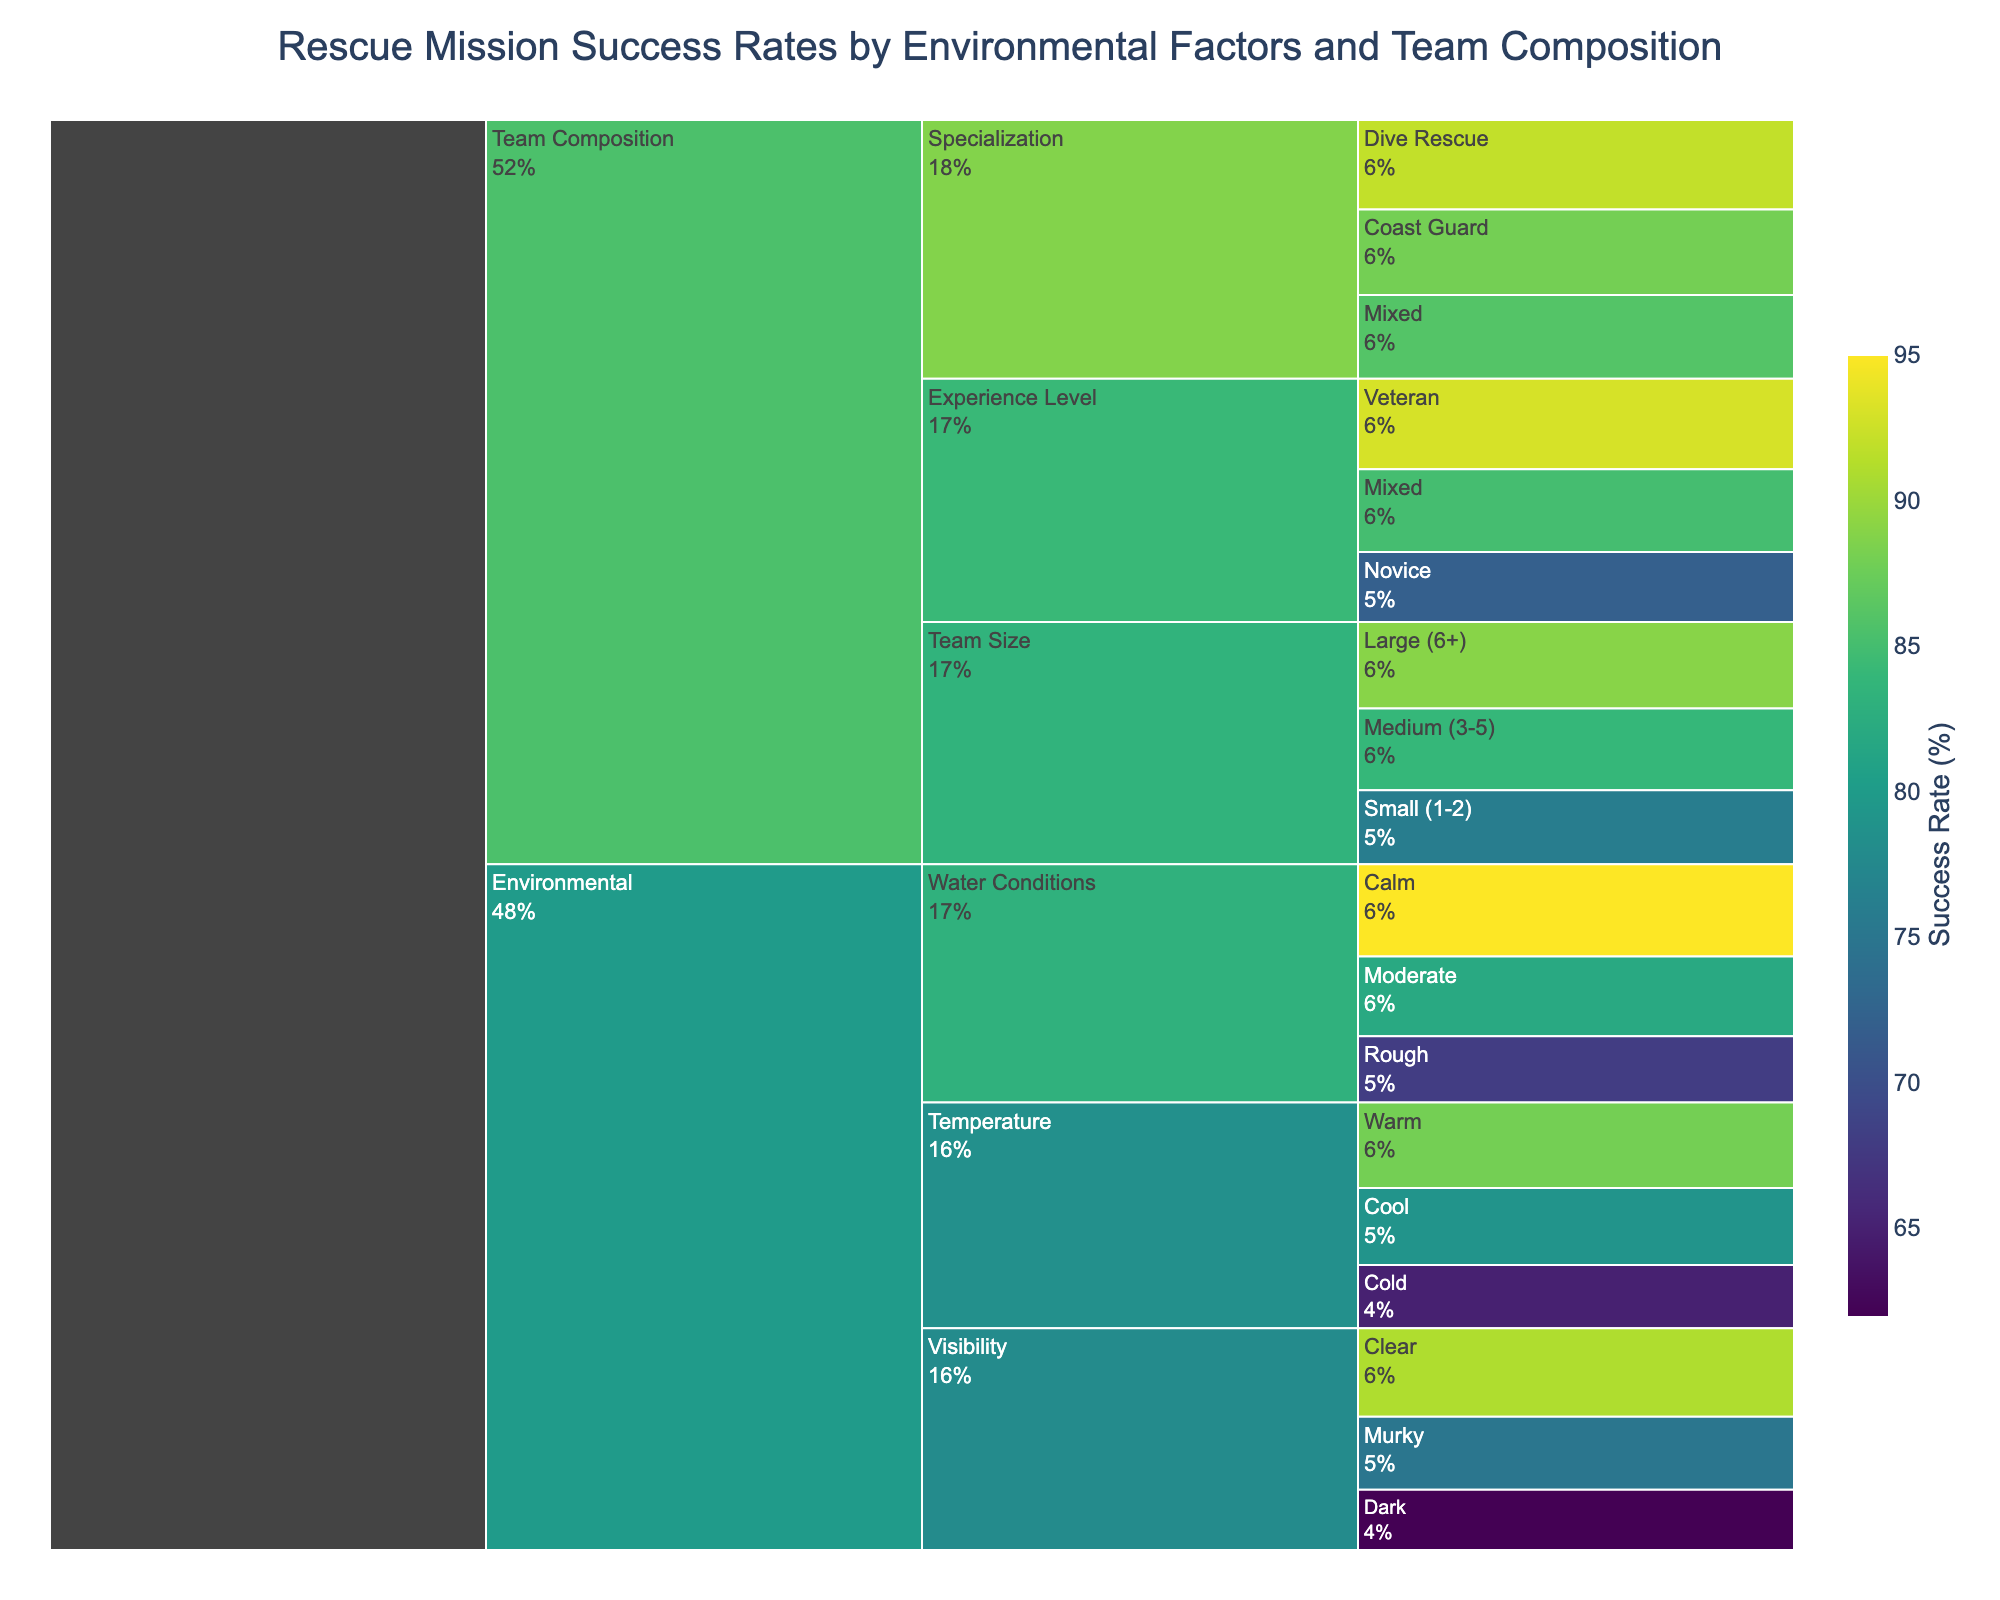What's the success rate for rescue missions in calm water conditions? Look for the Water Conditions sub-factor under Environmental factors and identify the success rate for the Calm category.
Answer: 95% What is the title of the icicle chart? Identify the text at the top center of the chart which serves as the title.
Answer: Rescue Mission Success Rates by Environmental Factors and Team Composition How does the success rate for veteran rescue teams compare to novice teams? Locate the Experience Level sub-factor under Team Composition. Compare the values under Veteran and Novice categories.
Answer: Veteran teams have a higher success rate (93% vs. 72%) What is the average success rate for rescue missions in cold temperatures, murky water, and small teams? Identify the success rates for Cold temperature (65%), Murky water (75%), and Small teams (76%). Compute the average: (65 + 75 + 76) / 3 = 72%.
Answer: 72% Which sub-factor has the lowest success rate, and what is the value? Scan through all sub-factors under both Environmental and Team Composition to find the lowest success rate, which is for Dark visibility.
Answer: Dark visibility at 62% Which factor, environmental or team composition, has the sub-factor with the highest success rate? Compare the highest success rates under both main categories. Environmental has Calm water conditions at 95%, while Team Composition has Veteran experience at 93%.
Answer: Environmental (Calm water conditions at 95%) If a mission involves murky water and a mixed experience level team, what would be the success rate? Find the success rate for Murky water (75%) and Mixed experience level (85%). Both rates are separate, so the mission context may allow an average as an approximate measure: (75 + 85) / 2 = 80% (this is hypothetical and assumes equal weight).
Answer: Approximately 80% What is the success rate range for different team sizes? Identify the success rates for Large (89%), Medium (84%), and Small teams (76%). Calculate the range by subtracting the smallest value from the largest: 89 - 76 = 13%.
Answer: 13% Which environmental factor—temperature, visibility, or water conditions—has the highest overall success rate, and which sub-factor represents it? Identify the highest success rates under Temperature (Warm, 88%), Visibility (Clear, 91%), and Water Conditions (Calm, 95%).
Answer: Water Conditions (Calm at 95%) What is the success rate for mixed specialization teams compared to dive rescue teams? Look for the sub-factor Specialization under Team Composition and compare Mixed (86%) with Dive Rescue (92%) teams.
Answer: Dive Rescue teams have a higher success rate (92% vs. 86%) 